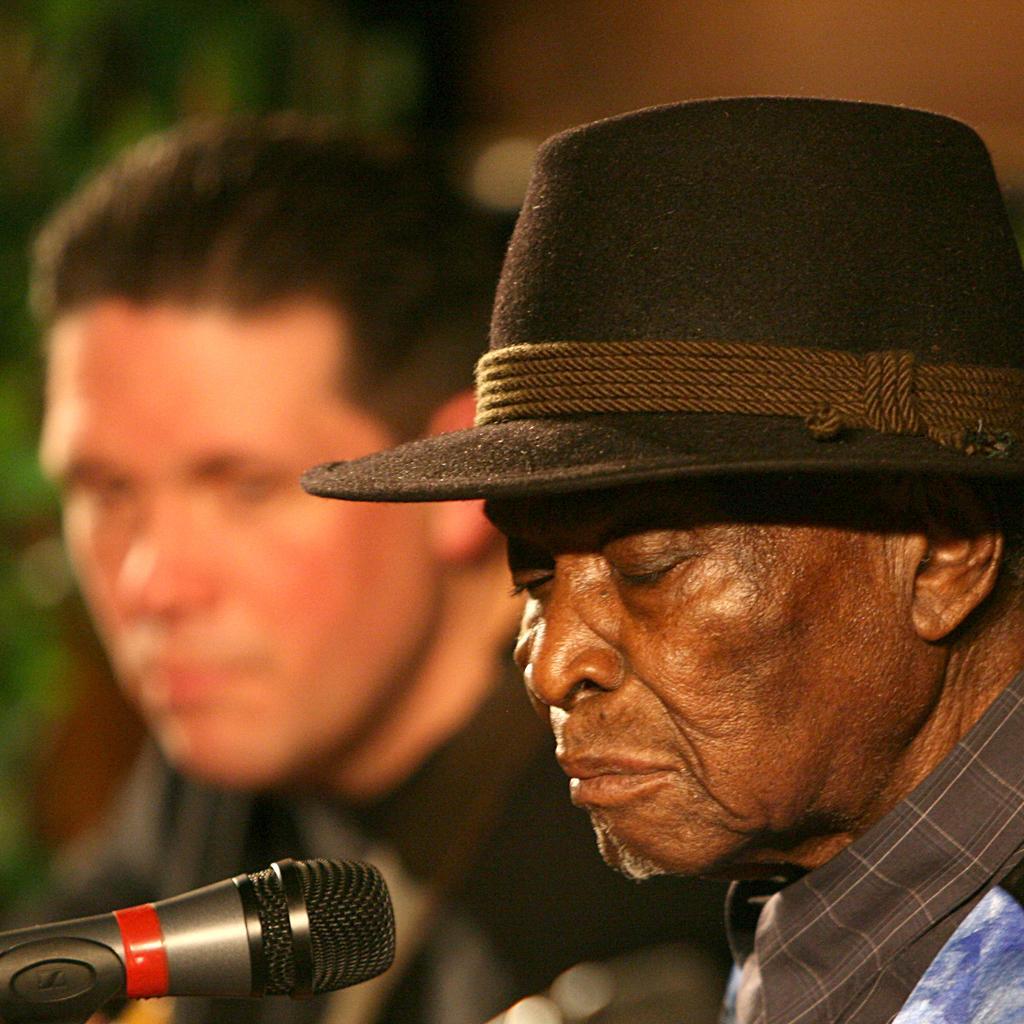Please provide a concise description of this image. In this image, on the right side, we can see a man wearing a black color hat is in front of a microphone which is in the left corner. In the background, we can see a man and green color. 